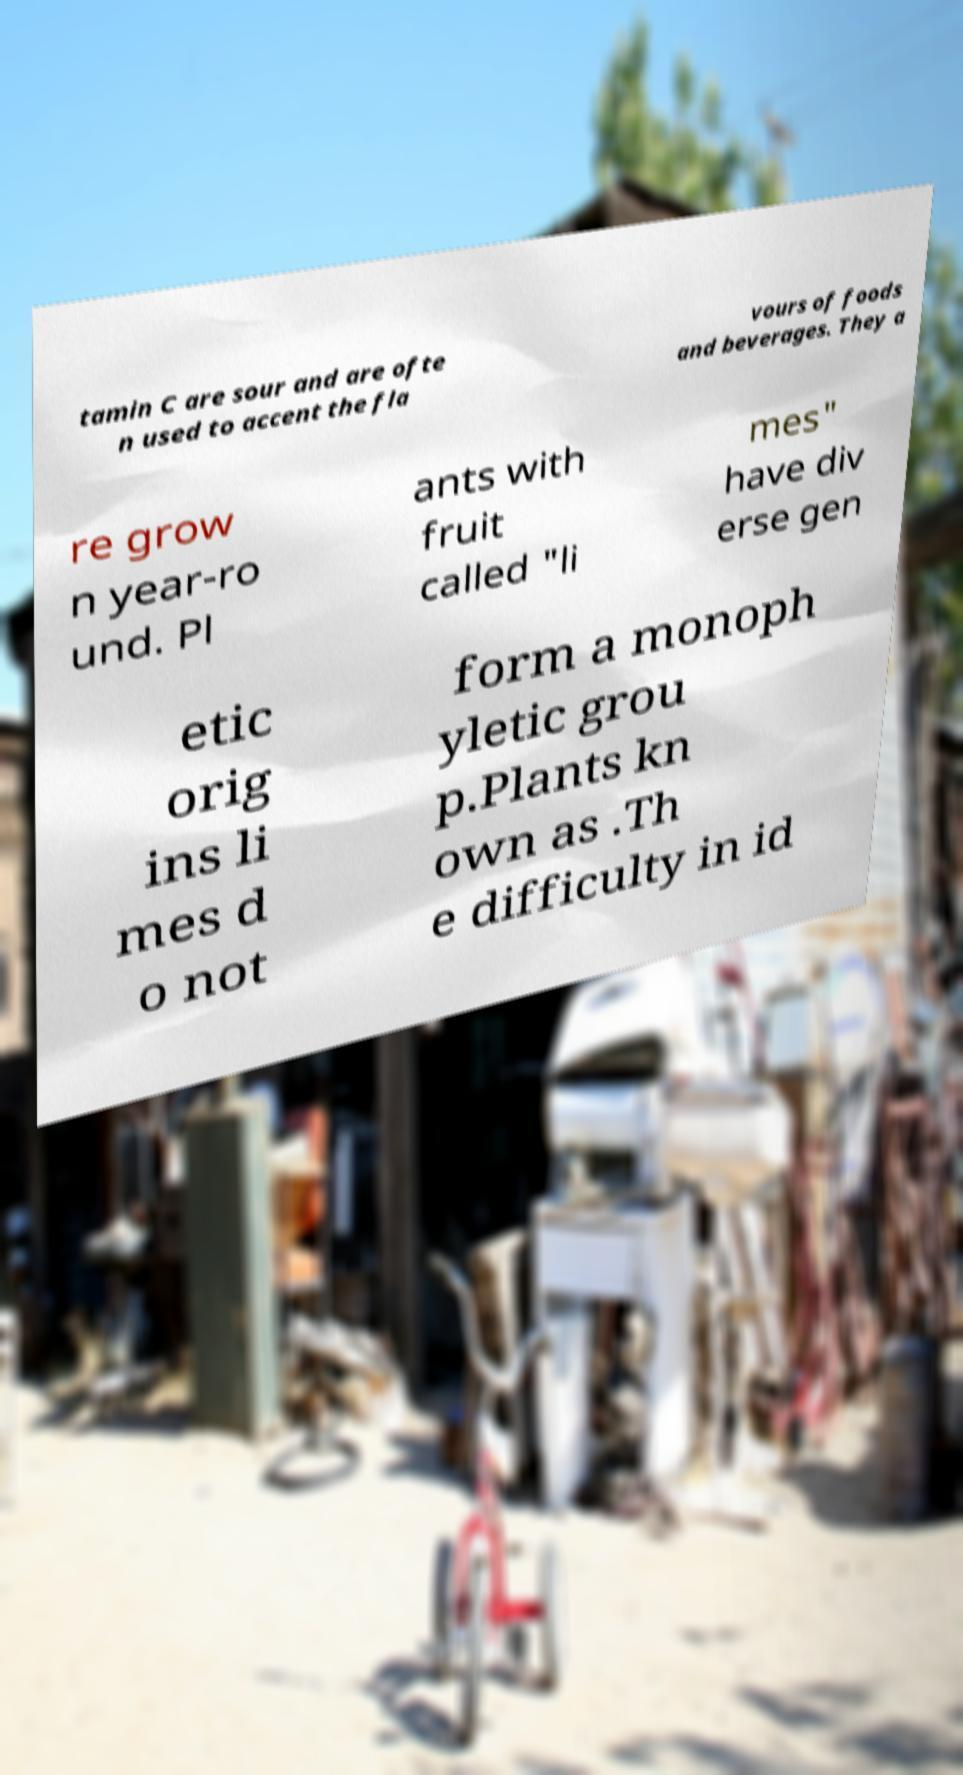Could you assist in decoding the text presented in this image and type it out clearly? tamin C are sour and are ofte n used to accent the fla vours of foods and beverages. They a re grow n year-ro und. Pl ants with fruit called "li mes" have div erse gen etic orig ins li mes d o not form a monoph yletic grou p.Plants kn own as .Th e difficulty in id 